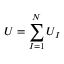Convert formula to latex. <formula><loc_0><loc_0><loc_500><loc_500>U = \sum _ { I = 1 } ^ { N } U _ { I }</formula> 